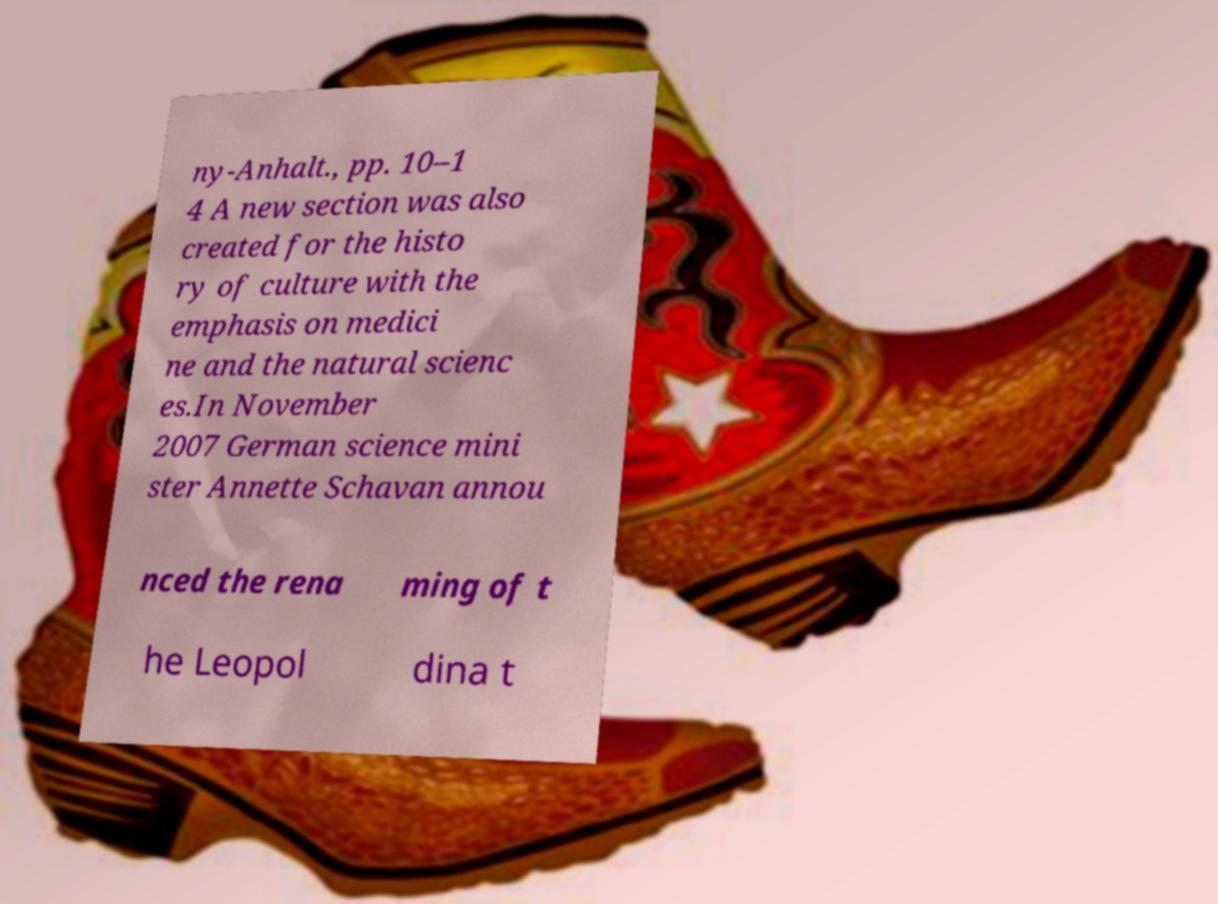Can you accurately transcribe the text from the provided image for me? ny-Anhalt., pp. 10–1 4 A new section was also created for the histo ry of culture with the emphasis on medici ne and the natural scienc es.In November 2007 German science mini ster Annette Schavan annou nced the rena ming of t he Leopol dina t 